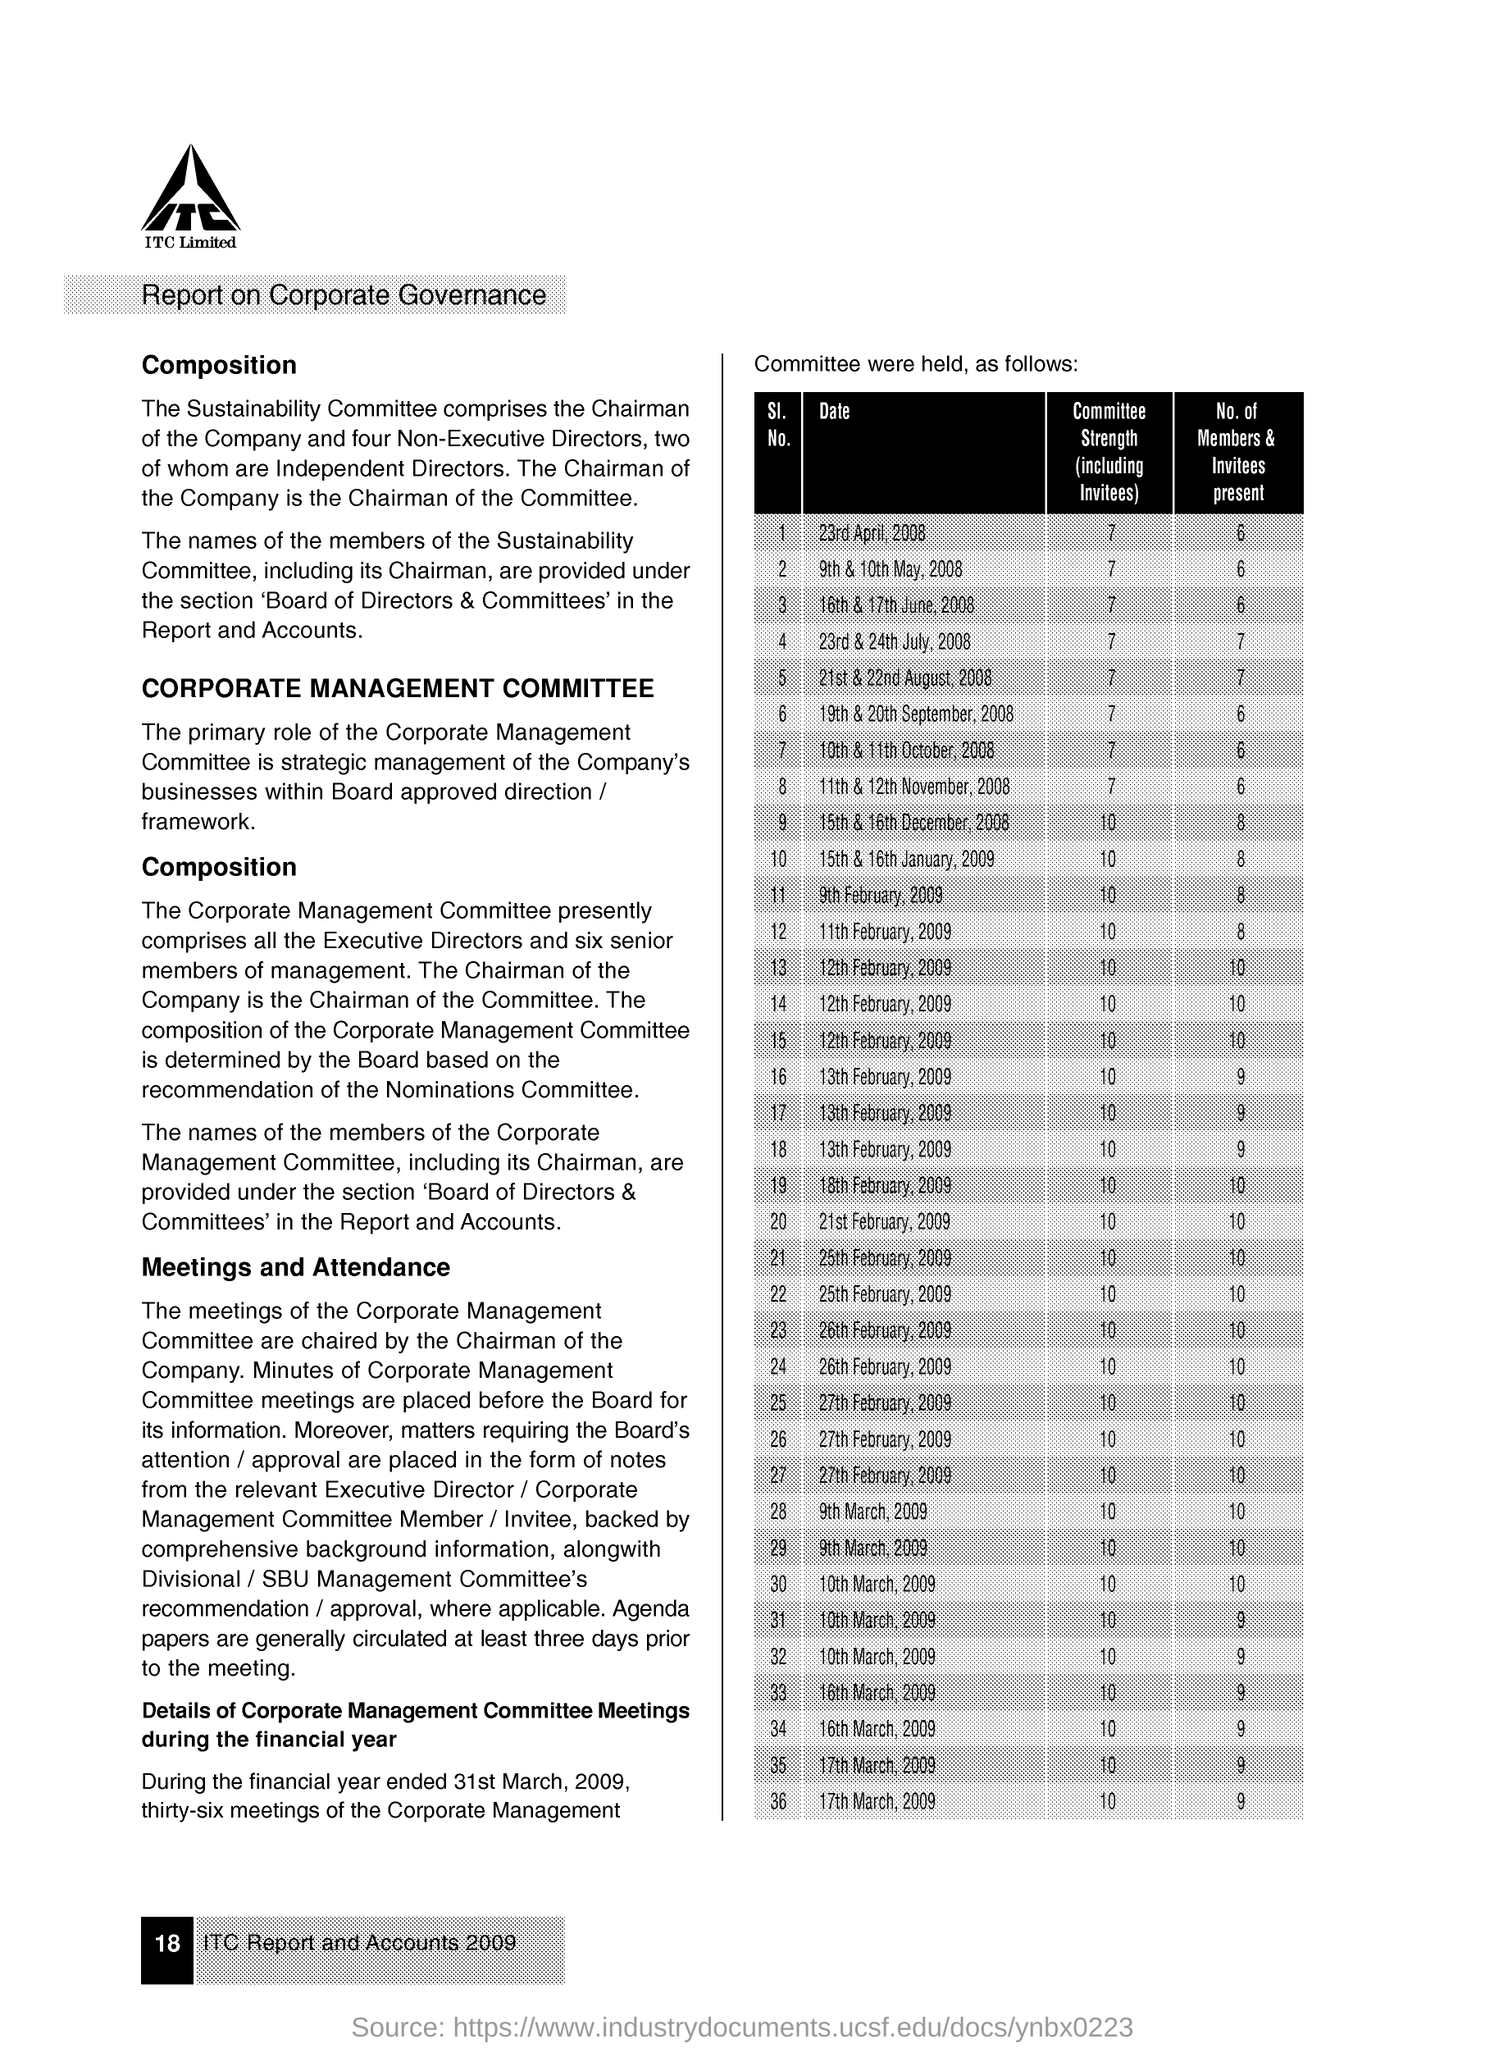Give some essential details in this illustration. The company name is ITC Limited. 